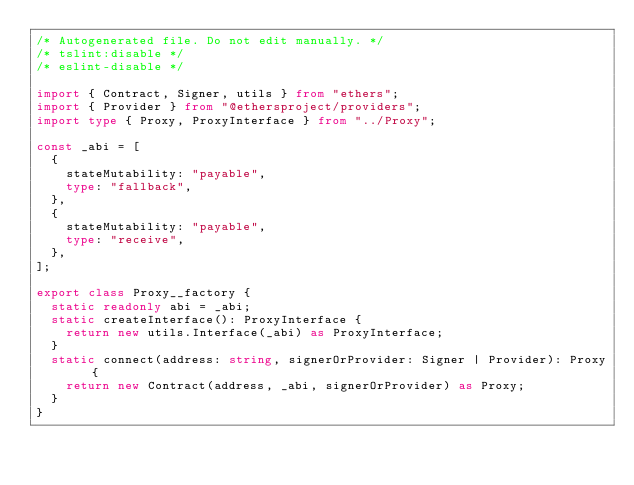<code> <loc_0><loc_0><loc_500><loc_500><_TypeScript_>/* Autogenerated file. Do not edit manually. */
/* tslint:disable */
/* eslint-disable */

import { Contract, Signer, utils } from "ethers";
import { Provider } from "@ethersproject/providers";
import type { Proxy, ProxyInterface } from "../Proxy";

const _abi = [
  {
    stateMutability: "payable",
    type: "fallback",
  },
  {
    stateMutability: "payable",
    type: "receive",
  },
];

export class Proxy__factory {
  static readonly abi = _abi;
  static createInterface(): ProxyInterface {
    return new utils.Interface(_abi) as ProxyInterface;
  }
  static connect(address: string, signerOrProvider: Signer | Provider): Proxy {
    return new Contract(address, _abi, signerOrProvider) as Proxy;
  }
}
</code> 